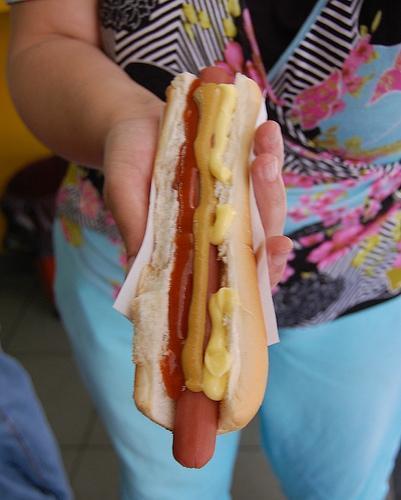How many hot dogs are there?
Give a very brief answer. 1. How many fingers do you see?
Give a very brief answer. 4. How many people are there?
Give a very brief answer. 1. How many train cars have some yellow on them?
Give a very brief answer. 0. 